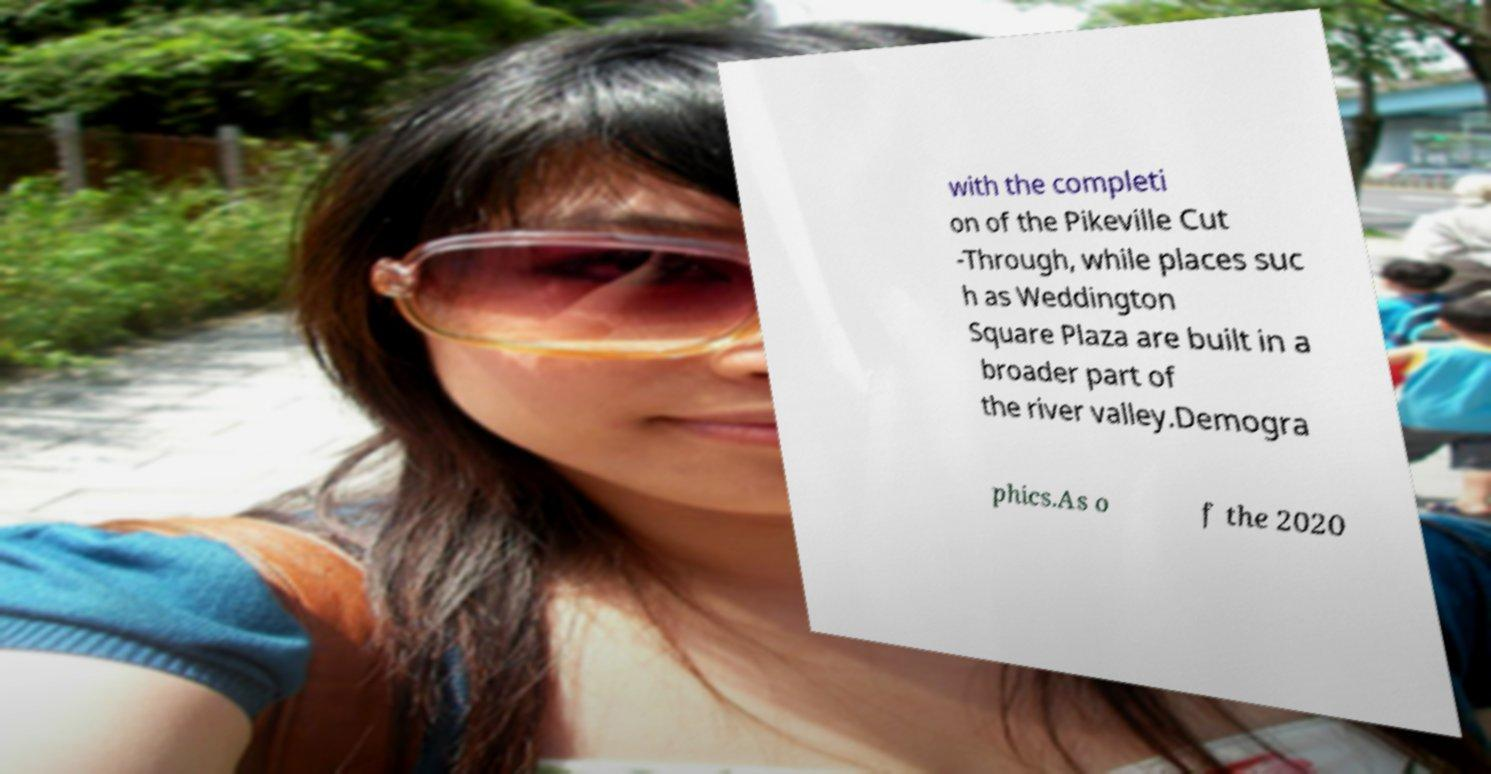I need the written content from this picture converted into text. Can you do that? with the completi on of the Pikeville Cut -Through, while places suc h as Weddington Square Plaza are built in a broader part of the river valley.Demogra phics.As o f the 2020 